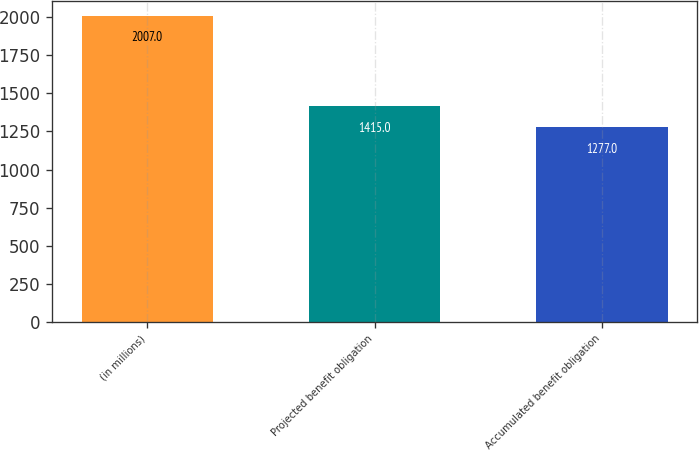<chart> <loc_0><loc_0><loc_500><loc_500><bar_chart><fcel>(in millions)<fcel>Projected benefit obligation<fcel>Accumulated benefit obligation<nl><fcel>2007<fcel>1415<fcel>1277<nl></chart> 